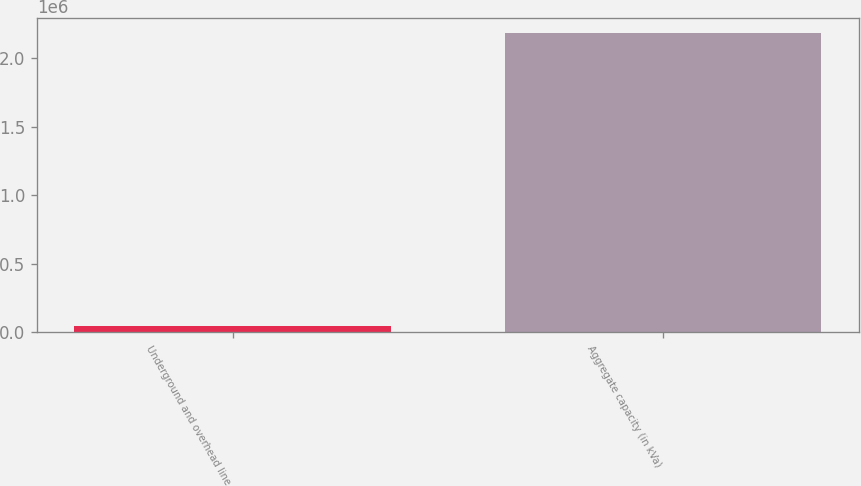Convert chart to OTSL. <chart><loc_0><loc_0><loc_500><loc_500><bar_chart><fcel>Underground and overhead line<fcel>Aggregate capacity (in kVa)<nl><fcel>42950<fcel>2.18352e+06<nl></chart> 